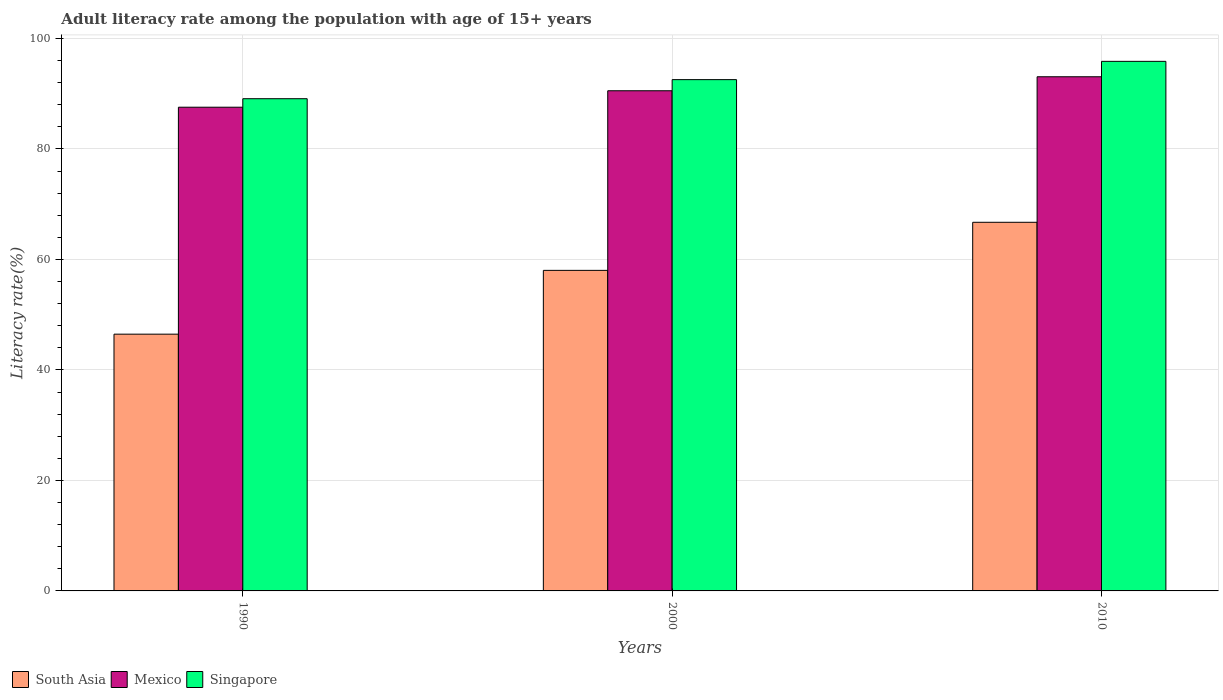How many different coloured bars are there?
Make the answer very short. 3. What is the label of the 2nd group of bars from the left?
Your answer should be very brief. 2000. What is the adult literacy rate in South Asia in 2000?
Your response must be concise. 58.02. Across all years, what is the maximum adult literacy rate in Singapore?
Provide a short and direct response. 95.86. Across all years, what is the minimum adult literacy rate in Mexico?
Ensure brevity in your answer.  87.56. In which year was the adult literacy rate in South Asia maximum?
Give a very brief answer. 2010. In which year was the adult literacy rate in Mexico minimum?
Your answer should be very brief. 1990. What is the total adult literacy rate in Singapore in the graph?
Keep it short and to the point. 277.5. What is the difference between the adult literacy rate in Singapore in 2000 and that in 2010?
Make the answer very short. -3.31. What is the difference between the adult literacy rate in Mexico in 2000 and the adult literacy rate in Singapore in 1990?
Your response must be concise. 1.44. What is the average adult literacy rate in South Asia per year?
Provide a short and direct response. 57.08. In the year 1990, what is the difference between the adult literacy rate in South Asia and adult literacy rate in Mexico?
Give a very brief answer. -41.08. What is the ratio of the adult literacy rate in South Asia in 2000 to that in 2010?
Your answer should be very brief. 0.87. Is the difference between the adult literacy rate in South Asia in 1990 and 2010 greater than the difference between the adult literacy rate in Mexico in 1990 and 2010?
Your response must be concise. No. What is the difference between the highest and the second highest adult literacy rate in Mexico?
Your answer should be compact. 2.53. What is the difference between the highest and the lowest adult literacy rate in South Asia?
Offer a terse response. 20.25. In how many years, is the adult literacy rate in Mexico greater than the average adult literacy rate in Mexico taken over all years?
Offer a terse response. 2. Is the sum of the adult literacy rate in Mexico in 1990 and 2000 greater than the maximum adult literacy rate in Singapore across all years?
Your answer should be very brief. Yes. What does the 1st bar from the right in 2000 represents?
Your answer should be compact. Singapore. Is it the case that in every year, the sum of the adult literacy rate in South Asia and adult literacy rate in Singapore is greater than the adult literacy rate in Mexico?
Offer a very short reply. Yes. Are all the bars in the graph horizontal?
Provide a short and direct response. No. How many years are there in the graph?
Make the answer very short. 3. Are the values on the major ticks of Y-axis written in scientific E-notation?
Offer a terse response. No. Does the graph contain any zero values?
Keep it short and to the point. No. Does the graph contain grids?
Your answer should be compact. Yes. Where does the legend appear in the graph?
Your response must be concise. Bottom left. How are the legend labels stacked?
Make the answer very short. Horizontal. What is the title of the graph?
Keep it short and to the point. Adult literacy rate among the population with age of 15+ years. What is the label or title of the X-axis?
Provide a short and direct response. Years. What is the label or title of the Y-axis?
Make the answer very short. Literacy rate(%). What is the Literacy rate(%) in South Asia in 1990?
Offer a terse response. 46.48. What is the Literacy rate(%) of Mexico in 1990?
Give a very brief answer. 87.56. What is the Literacy rate(%) in Singapore in 1990?
Offer a very short reply. 89.1. What is the Literacy rate(%) of South Asia in 2000?
Make the answer very short. 58.02. What is the Literacy rate(%) in Mexico in 2000?
Keep it short and to the point. 90.54. What is the Literacy rate(%) in Singapore in 2000?
Keep it short and to the point. 92.55. What is the Literacy rate(%) of South Asia in 2010?
Give a very brief answer. 66.73. What is the Literacy rate(%) of Mexico in 2010?
Your response must be concise. 93.07. What is the Literacy rate(%) in Singapore in 2010?
Your answer should be compact. 95.86. Across all years, what is the maximum Literacy rate(%) in South Asia?
Make the answer very short. 66.73. Across all years, what is the maximum Literacy rate(%) of Mexico?
Keep it short and to the point. 93.07. Across all years, what is the maximum Literacy rate(%) of Singapore?
Provide a succinct answer. 95.86. Across all years, what is the minimum Literacy rate(%) of South Asia?
Your response must be concise. 46.48. Across all years, what is the minimum Literacy rate(%) of Mexico?
Provide a short and direct response. 87.56. Across all years, what is the minimum Literacy rate(%) in Singapore?
Your answer should be compact. 89.1. What is the total Literacy rate(%) in South Asia in the graph?
Your answer should be compact. 171.23. What is the total Literacy rate(%) of Mexico in the graph?
Give a very brief answer. 271.16. What is the total Literacy rate(%) of Singapore in the graph?
Give a very brief answer. 277.5. What is the difference between the Literacy rate(%) of South Asia in 1990 and that in 2000?
Provide a short and direct response. -11.55. What is the difference between the Literacy rate(%) of Mexico in 1990 and that in 2000?
Your response must be concise. -2.98. What is the difference between the Literacy rate(%) of Singapore in 1990 and that in 2000?
Your answer should be compact. -3.45. What is the difference between the Literacy rate(%) in South Asia in 1990 and that in 2010?
Keep it short and to the point. -20.25. What is the difference between the Literacy rate(%) of Mexico in 1990 and that in 2010?
Your answer should be very brief. -5.51. What is the difference between the Literacy rate(%) of Singapore in 1990 and that in 2010?
Keep it short and to the point. -6.76. What is the difference between the Literacy rate(%) in South Asia in 2000 and that in 2010?
Make the answer very short. -8.7. What is the difference between the Literacy rate(%) in Mexico in 2000 and that in 2010?
Your answer should be compact. -2.53. What is the difference between the Literacy rate(%) in Singapore in 2000 and that in 2010?
Your answer should be compact. -3.31. What is the difference between the Literacy rate(%) of South Asia in 1990 and the Literacy rate(%) of Mexico in 2000?
Provide a short and direct response. -44.06. What is the difference between the Literacy rate(%) of South Asia in 1990 and the Literacy rate(%) of Singapore in 2000?
Offer a terse response. -46.07. What is the difference between the Literacy rate(%) in Mexico in 1990 and the Literacy rate(%) in Singapore in 2000?
Keep it short and to the point. -4.99. What is the difference between the Literacy rate(%) in South Asia in 1990 and the Literacy rate(%) in Mexico in 2010?
Keep it short and to the point. -46.59. What is the difference between the Literacy rate(%) in South Asia in 1990 and the Literacy rate(%) in Singapore in 2010?
Offer a terse response. -49.38. What is the difference between the Literacy rate(%) of Mexico in 1990 and the Literacy rate(%) of Singapore in 2010?
Your answer should be very brief. -8.3. What is the difference between the Literacy rate(%) of South Asia in 2000 and the Literacy rate(%) of Mexico in 2010?
Give a very brief answer. -35.05. What is the difference between the Literacy rate(%) in South Asia in 2000 and the Literacy rate(%) in Singapore in 2010?
Keep it short and to the point. -37.83. What is the difference between the Literacy rate(%) of Mexico in 2000 and the Literacy rate(%) of Singapore in 2010?
Offer a very short reply. -5.32. What is the average Literacy rate(%) in South Asia per year?
Make the answer very short. 57.08. What is the average Literacy rate(%) of Mexico per year?
Offer a terse response. 90.39. What is the average Literacy rate(%) of Singapore per year?
Provide a short and direct response. 92.5. In the year 1990, what is the difference between the Literacy rate(%) of South Asia and Literacy rate(%) of Mexico?
Provide a short and direct response. -41.08. In the year 1990, what is the difference between the Literacy rate(%) in South Asia and Literacy rate(%) in Singapore?
Your answer should be compact. -42.62. In the year 1990, what is the difference between the Literacy rate(%) in Mexico and Literacy rate(%) in Singapore?
Make the answer very short. -1.54. In the year 2000, what is the difference between the Literacy rate(%) in South Asia and Literacy rate(%) in Mexico?
Ensure brevity in your answer.  -32.51. In the year 2000, what is the difference between the Literacy rate(%) in South Asia and Literacy rate(%) in Singapore?
Keep it short and to the point. -34.53. In the year 2000, what is the difference between the Literacy rate(%) in Mexico and Literacy rate(%) in Singapore?
Keep it short and to the point. -2.01. In the year 2010, what is the difference between the Literacy rate(%) of South Asia and Literacy rate(%) of Mexico?
Offer a terse response. -26.34. In the year 2010, what is the difference between the Literacy rate(%) of South Asia and Literacy rate(%) of Singapore?
Your answer should be compact. -29.13. In the year 2010, what is the difference between the Literacy rate(%) of Mexico and Literacy rate(%) of Singapore?
Keep it short and to the point. -2.79. What is the ratio of the Literacy rate(%) of South Asia in 1990 to that in 2000?
Offer a very short reply. 0.8. What is the ratio of the Literacy rate(%) of Mexico in 1990 to that in 2000?
Keep it short and to the point. 0.97. What is the ratio of the Literacy rate(%) in Singapore in 1990 to that in 2000?
Offer a terse response. 0.96. What is the ratio of the Literacy rate(%) in South Asia in 1990 to that in 2010?
Keep it short and to the point. 0.7. What is the ratio of the Literacy rate(%) of Mexico in 1990 to that in 2010?
Keep it short and to the point. 0.94. What is the ratio of the Literacy rate(%) of Singapore in 1990 to that in 2010?
Keep it short and to the point. 0.93. What is the ratio of the Literacy rate(%) in South Asia in 2000 to that in 2010?
Your response must be concise. 0.87. What is the ratio of the Literacy rate(%) in Mexico in 2000 to that in 2010?
Provide a succinct answer. 0.97. What is the ratio of the Literacy rate(%) in Singapore in 2000 to that in 2010?
Ensure brevity in your answer.  0.97. What is the difference between the highest and the second highest Literacy rate(%) of South Asia?
Give a very brief answer. 8.7. What is the difference between the highest and the second highest Literacy rate(%) in Mexico?
Ensure brevity in your answer.  2.53. What is the difference between the highest and the second highest Literacy rate(%) in Singapore?
Ensure brevity in your answer.  3.31. What is the difference between the highest and the lowest Literacy rate(%) in South Asia?
Offer a terse response. 20.25. What is the difference between the highest and the lowest Literacy rate(%) in Mexico?
Make the answer very short. 5.51. What is the difference between the highest and the lowest Literacy rate(%) of Singapore?
Offer a very short reply. 6.76. 